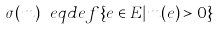<formula> <loc_0><loc_0><loc_500><loc_500>\sigma ( m ) \ e q d e f \{ e \in E | m ( e ) > 0 \}</formula> 